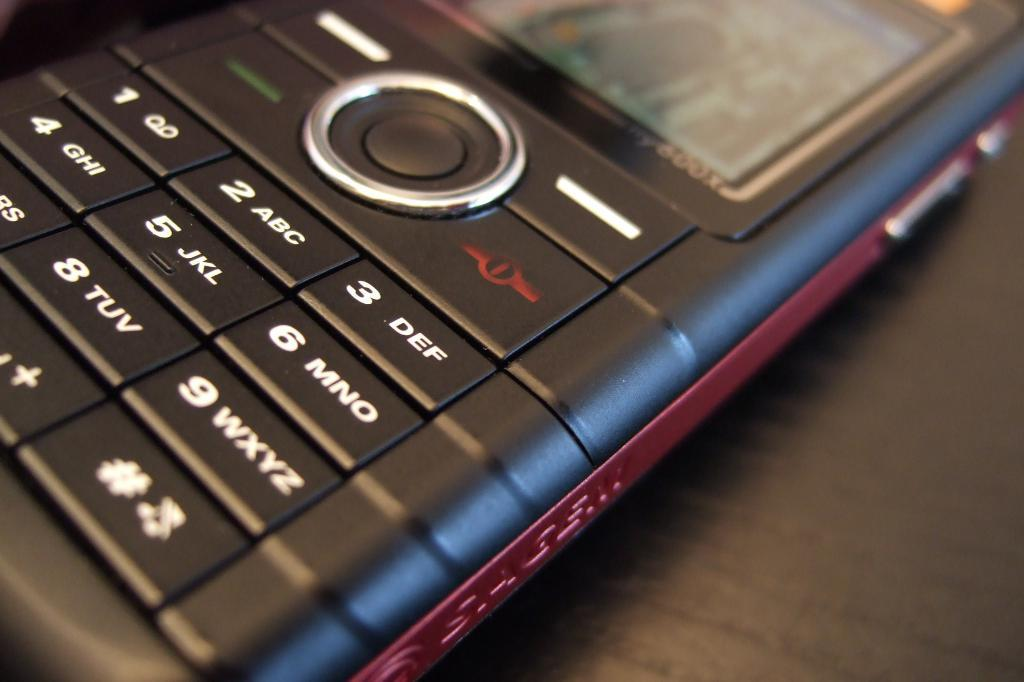What is the main object in the image? There is a mobile in the image. Where is the mobile located? The mobile is on a platform. What type of screw is holding the mobile to the platform in the image? There is no screw visible in the image, and the mobile's attachment to the platform is not mentioned in the provided facts. 